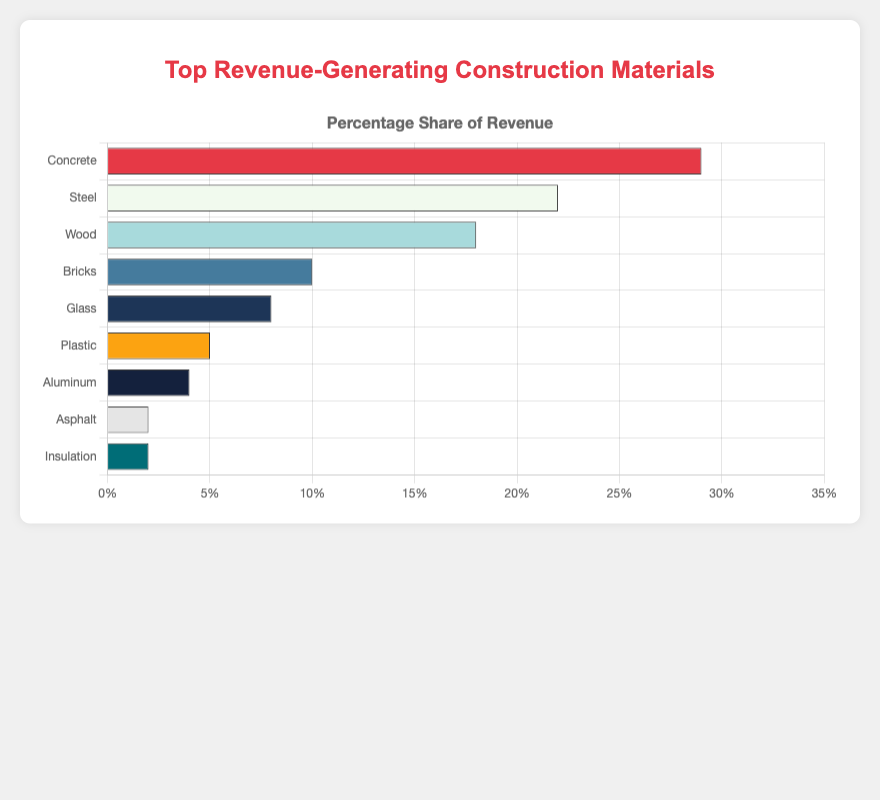Which construction material generates the highest revenue percentage? The construction material with the highest revenue percentage is identified as the one with the longest horizontal bar. In this case, it is Concrete at 29%.
Answer: Concrete Which material generates less revenue, Glass or Wood? Compare the lengths of the bars for Glass and Wood. Glass generates 8% revenue, while Wood generates 18%. Glass has a shorter bar.
Answer: Glass What is the combined revenue percentage of Asphalt and Insulation? Sum the revenue percentages of Asphalt (2%) and Insulation (2%): 2% + 2% = 4%.
Answer: 4% How much higher is the revenue percentage of Steel compared to Aluminum? The revenue percentages for Steel and Aluminum are 22% and 4%, respectively. The difference is calculated as 22% - 4% = 18%.
Answer: 18% Which material is represented by a blue bar and what is its revenue percentage? The color blue is associated with the fifth horizontal bar visually, which corresponds to Glass. Glass has a revenue percentage of 8%.
Answer: Glass, 8% Does Wood generate more revenue than Bricks and Plastic combined? The revenue percentage for Wood is 18%. The combined revenue percentage for Bricks (10%) and Plastic (5%) is 15% (10% + 5%). So, Wood generates more revenue.
Answer: Yes What is the relative position of Steel in the chart regarding revenue percentage? Steel has the second longest bar, indicating it is the second highest in revenue percentage.
Answer: Second What is the average revenue percentage of the top three revenue-generating materials? The top three materials by revenue are Concrete (29%), Steel (22%), and Wood (18%). The average is calculated as (29% + 22% + 18%) / 3 = 69% / 3 = 23%.
Answer: 23% Which two materials have equal revenue percentages and what is that percentage? Both Asphalt and Insulation have a revenue percentage of 2%, as indicated by bars of equal length.
Answer: Asphalt and Insulation, 2% 